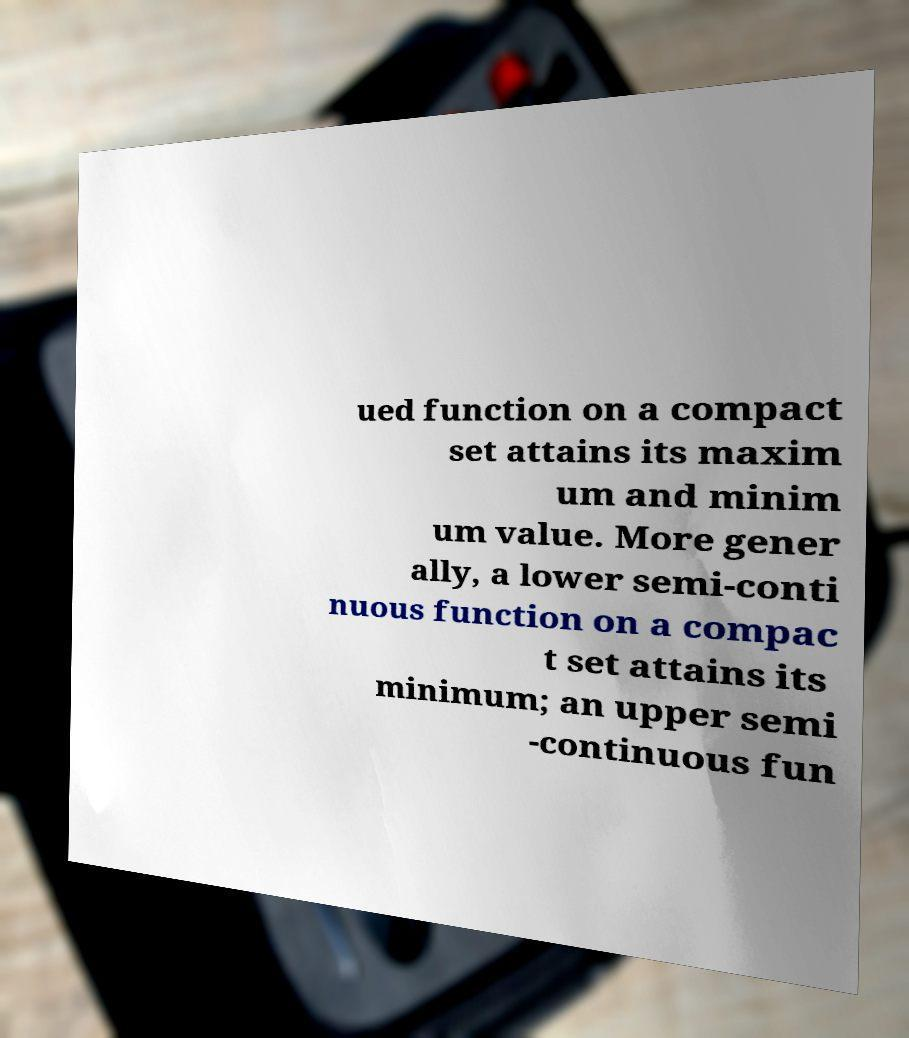Can you read and provide the text displayed in the image?This photo seems to have some interesting text. Can you extract and type it out for me? ued function on a compact set attains its maxim um and minim um value. More gener ally, a lower semi-conti nuous function on a compac t set attains its minimum; an upper semi -continuous fun 